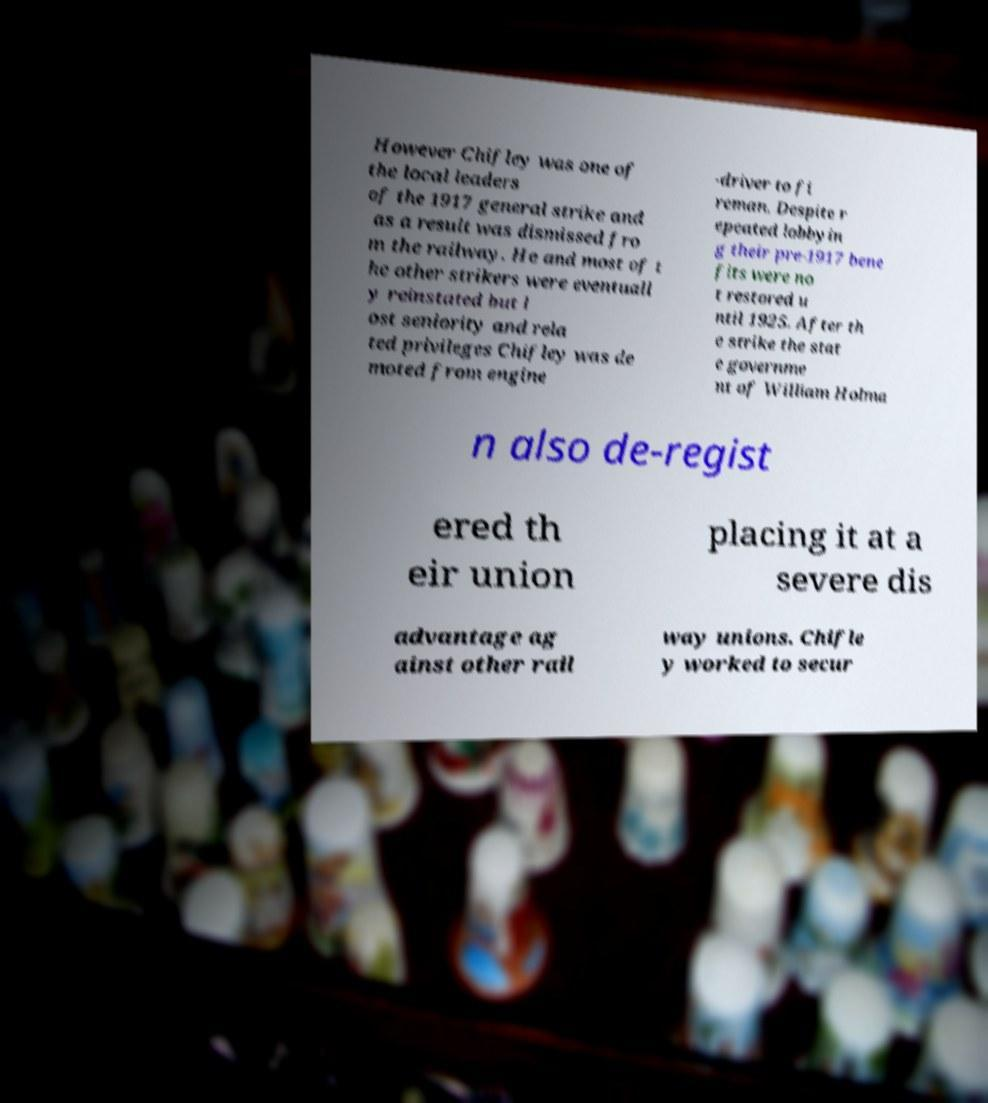I need the written content from this picture converted into text. Can you do that? However Chifley was one of the local leaders of the 1917 general strike and as a result was dismissed fro m the railway. He and most of t he other strikers were eventuall y reinstated but l ost seniority and rela ted privileges Chifley was de moted from engine -driver to fi reman. Despite r epeated lobbyin g their pre-1917 bene fits were no t restored u ntil 1925. After th e strike the stat e governme nt of William Holma n also de-regist ered th eir union placing it at a severe dis advantage ag ainst other rail way unions. Chifle y worked to secur 